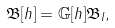<formula> <loc_0><loc_0><loc_500><loc_500>\mathfrak { B } [ h ] = \mathbb { G } [ h ] \mathfrak { B } _ { I } ,</formula> 